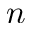Convert formula to latex. <formula><loc_0><loc_0><loc_500><loc_500>n</formula> 